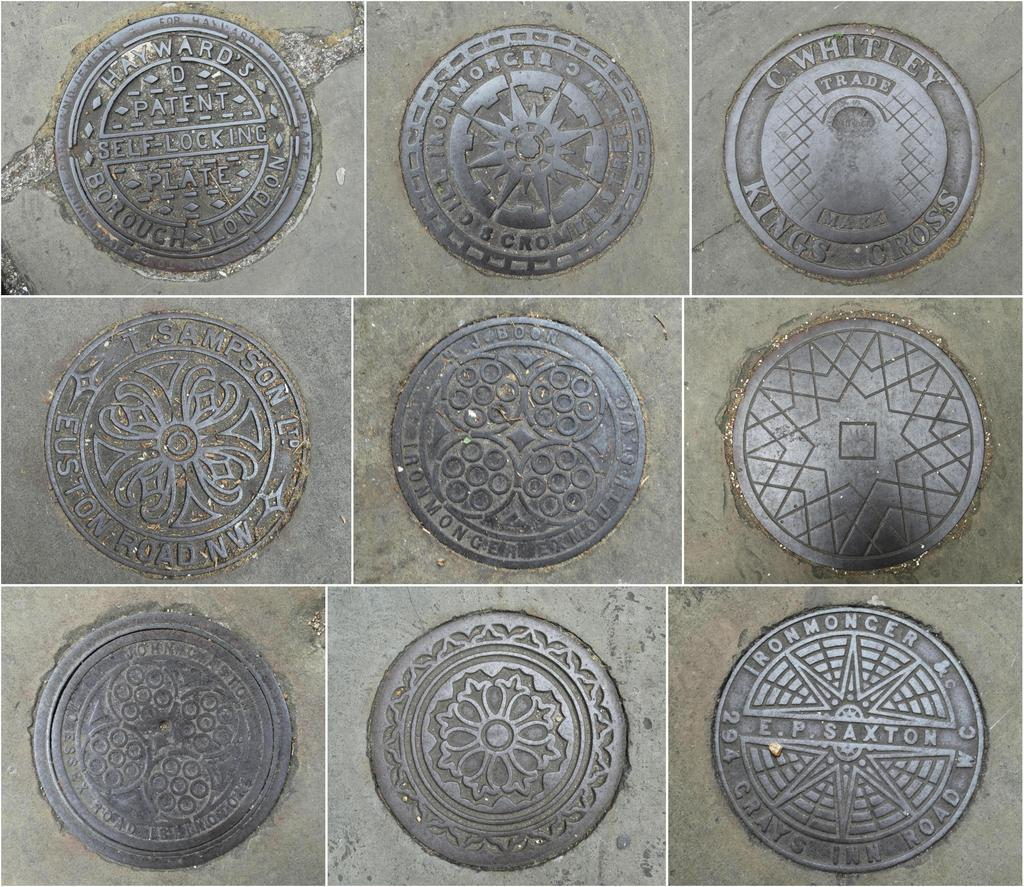What objects can be seen in the image? There are coins in the image. What material are the coins made of? The coins are made of iron. What type of boat can be seen in the image? There is no boat present in the image; it only contains coins made of iron. What kind of voice can be heard coming from the coins in the image? Coins do not have the ability to produce a voice, so there is no voice present in the image. 